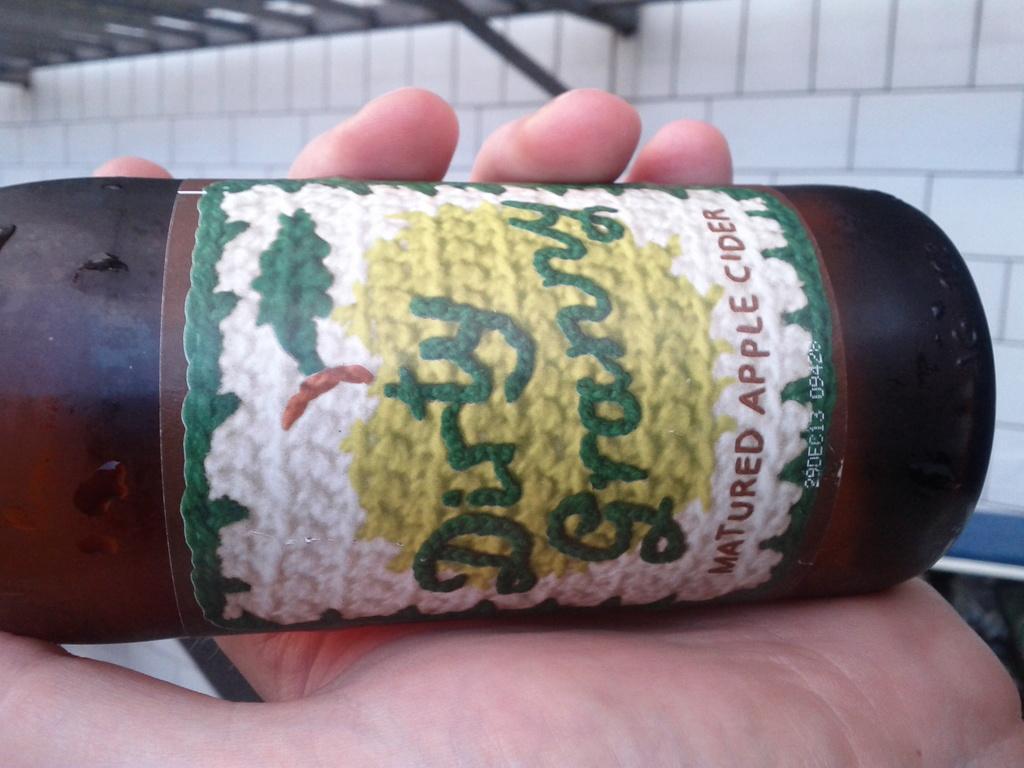How would you summarize this image in a sentence or two? In this image I can see a human hand is holding a bottle, there is a label on it. At the top it looks like a wall. 